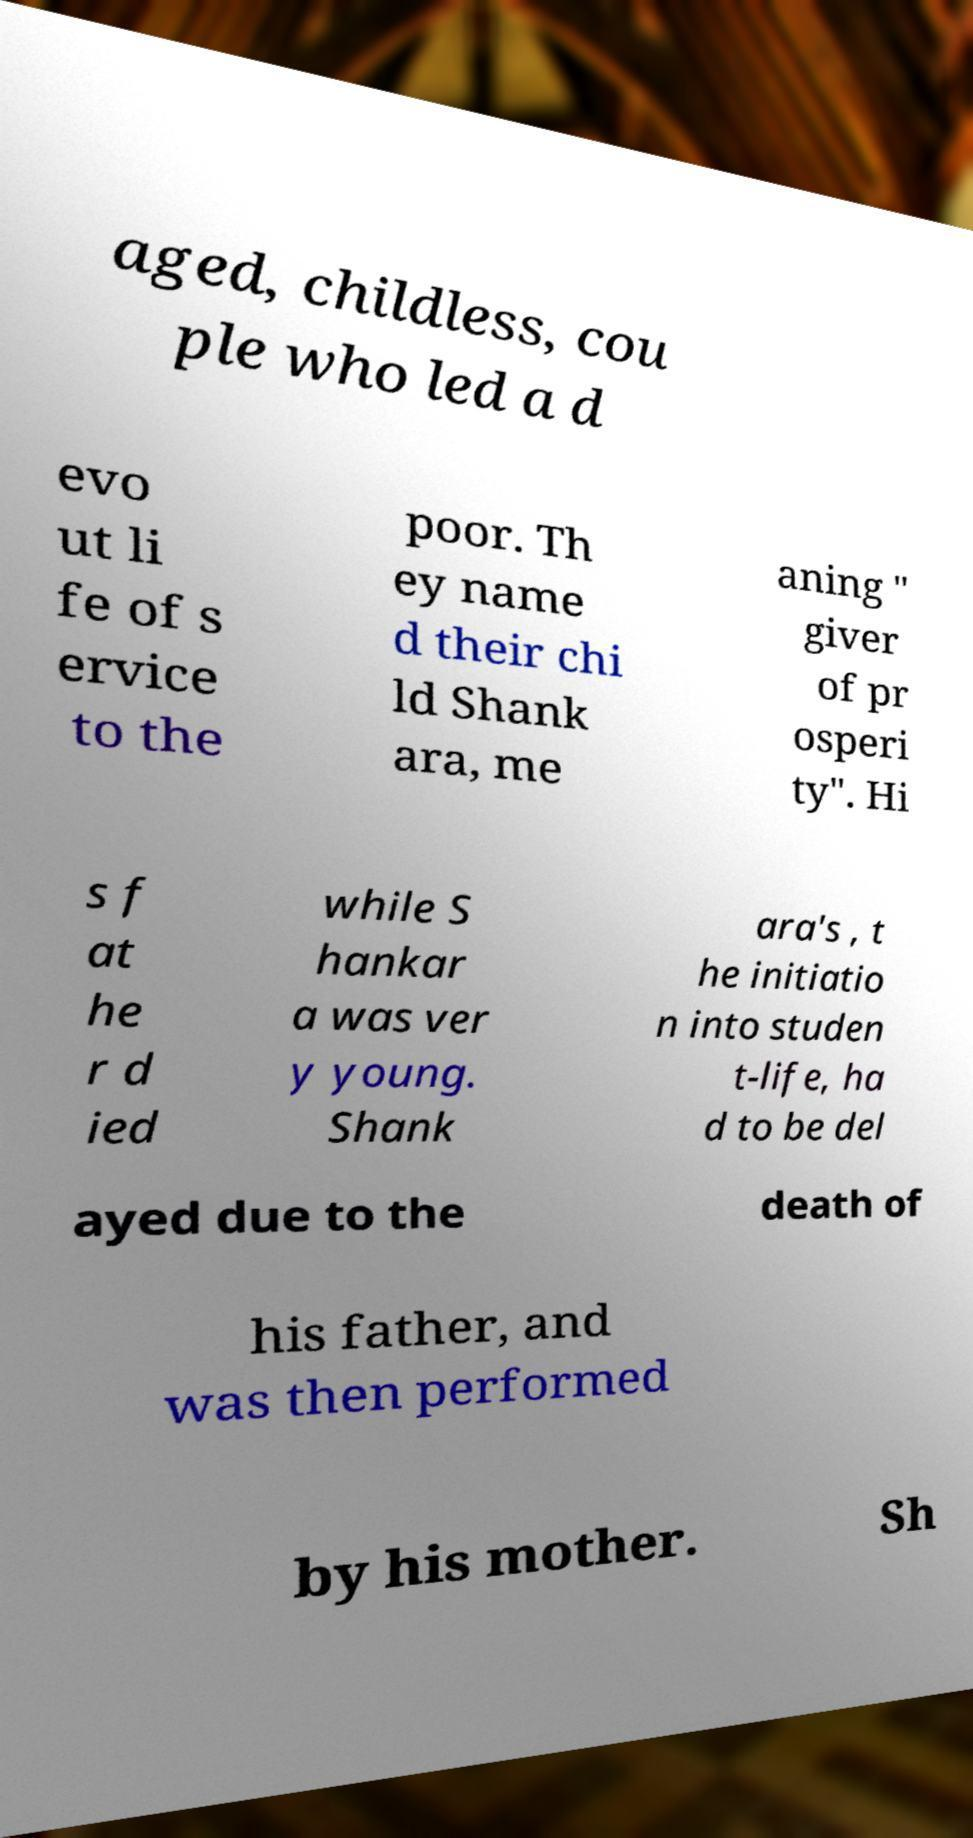Please read and relay the text visible in this image. What does it say? aged, childless, cou ple who led a d evo ut li fe of s ervice to the poor. Th ey name d their chi ld Shank ara, me aning " giver of pr osperi ty". Hi s f at he r d ied while S hankar a was ver y young. Shank ara's , t he initiatio n into studen t-life, ha d to be del ayed due to the death of his father, and was then performed by his mother. Sh 